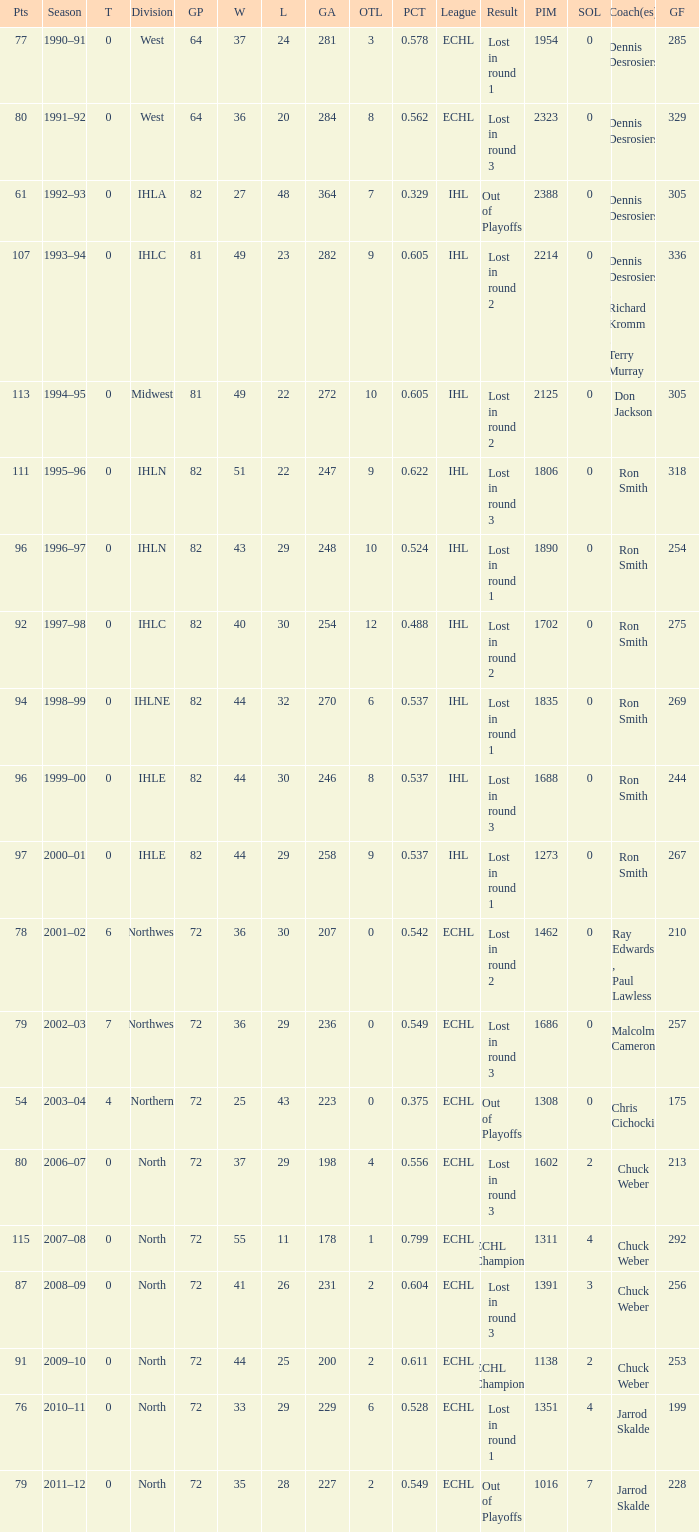Can you give me this table as a dict? {'header': ['Pts', 'Season', 'T', 'Division', 'GP', 'W', 'L', 'GA', 'OTL', 'PCT', 'League', 'Result', 'PIM', 'SOL', 'Coach(es)', 'GF'], 'rows': [['77', '1990–91', '0', 'West', '64', '37', '24', '281', '3', '0.578', 'ECHL', 'Lost in round 1', '1954', '0', 'Dennis Desrosiers', '285'], ['80', '1991–92', '0', 'West', '64', '36', '20', '284', '8', '0.562', 'ECHL', 'Lost in round 3', '2323', '0', 'Dennis Desrosiers', '329'], ['61', '1992–93', '0', 'IHLA', '82', '27', '48', '364', '7', '0.329', 'IHL', 'Out of Playoffs', '2388', '0', 'Dennis Desrosiers', '305'], ['107', '1993–94', '0', 'IHLC', '81', '49', '23', '282', '9', '0.605', 'IHL', 'Lost in round 2', '2214', '0', 'Dennis Desrosiers , Richard Kromm , Terry Murray', '336'], ['113', '1994–95', '0', 'Midwest', '81', '49', '22', '272', '10', '0.605', 'IHL', 'Lost in round 2', '2125', '0', 'Don Jackson', '305'], ['111', '1995–96', '0', 'IHLN', '82', '51', '22', '247', '9', '0.622', 'IHL', 'Lost in round 3', '1806', '0', 'Ron Smith', '318'], ['96', '1996–97', '0', 'IHLN', '82', '43', '29', '248', '10', '0.524', 'IHL', 'Lost in round 1', '1890', '0', 'Ron Smith', '254'], ['92', '1997–98', '0', 'IHLC', '82', '40', '30', '254', '12', '0.488', 'IHL', 'Lost in round 2', '1702', '0', 'Ron Smith', '275'], ['94', '1998–99', '0', 'IHLNE', '82', '44', '32', '270', '6', '0.537', 'IHL', 'Lost in round 1', '1835', '0', 'Ron Smith', '269'], ['96', '1999–00', '0', 'IHLE', '82', '44', '30', '246', '8', '0.537', 'IHL', 'Lost in round 3', '1688', '0', 'Ron Smith', '244'], ['97', '2000–01', '0', 'IHLE', '82', '44', '29', '258', '9', '0.537', 'IHL', 'Lost in round 1', '1273', '0', 'Ron Smith', '267'], ['78', '2001–02', '6', 'Northwest', '72', '36', '30', '207', '0', '0.542', 'ECHL', 'Lost in round 2', '1462', '0', 'Ray Edwards , Paul Lawless', '210'], ['79', '2002–03', '7', 'Northwest', '72', '36', '29', '236', '0', '0.549', 'ECHL', 'Lost in round 3', '1686', '0', 'Malcolm Cameron', '257'], ['54', '2003–04', '4', 'Northern', '72', '25', '43', '223', '0', '0.375', 'ECHL', 'Out of Playoffs', '1308', '0', 'Chris Cichocki', '175'], ['80', '2006–07', '0', 'North', '72', '37', '29', '198', '4', '0.556', 'ECHL', 'Lost in round 3', '1602', '2', 'Chuck Weber', '213'], ['115', '2007–08', '0', 'North', '72', '55', '11', '178', '1', '0.799', 'ECHL', 'ECHL Champions', '1311', '4', 'Chuck Weber', '292'], ['87', '2008–09', '0', 'North', '72', '41', '26', '231', '2', '0.604', 'ECHL', 'Lost in round 3', '1391', '3', 'Chuck Weber', '256'], ['91', '2009–10', '0', 'North', '72', '44', '25', '200', '2', '0.611', 'ECHL', 'ECHL Champions', '1138', '2', 'Chuck Weber', '253'], ['76', '2010–11', '0', 'North', '72', '33', '29', '229', '6', '0.528', 'ECHL', 'Lost in round 1', '1351', '4', 'Jarrod Skalde', '199'], ['79', '2011–12', '0', 'North', '72', '35', '28', '227', '2', '0.549', 'ECHL', 'Out of Playoffs', '1016', '7', 'Jarrod Skalde', '228']]} How many season did the team lost in round 1 with a GP of 64? 1.0. 